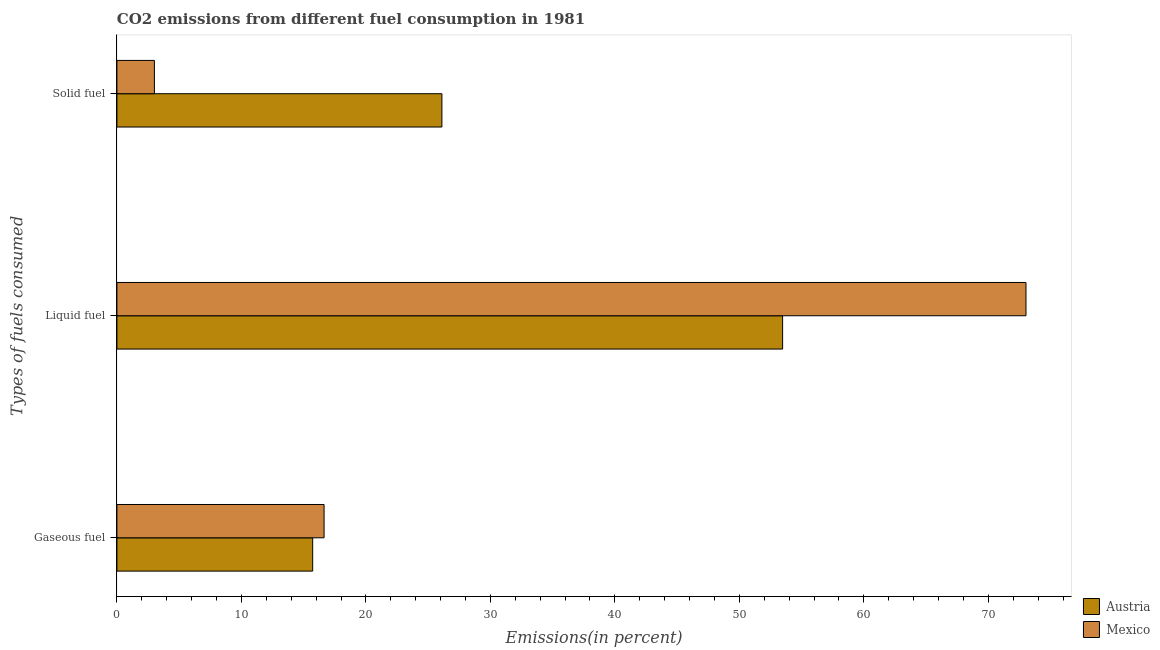How many different coloured bars are there?
Offer a terse response. 2. How many groups of bars are there?
Ensure brevity in your answer.  3. Are the number of bars on each tick of the Y-axis equal?
Your answer should be compact. Yes. How many bars are there on the 3rd tick from the top?
Your answer should be compact. 2. How many bars are there on the 3rd tick from the bottom?
Provide a succinct answer. 2. What is the label of the 3rd group of bars from the top?
Make the answer very short. Gaseous fuel. What is the percentage of liquid fuel emission in Austria?
Ensure brevity in your answer.  53.47. Across all countries, what is the maximum percentage of gaseous fuel emission?
Your response must be concise. 16.64. Across all countries, what is the minimum percentage of solid fuel emission?
Give a very brief answer. 3.01. In which country was the percentage of solid fuel emission minimum?
Make the answer very short. Mexico. What is the total percentage of solid fuel emission in the graph?
Your response must be concise. 29.12. What is the difference between the percentage of gaseous fuel emission in Austria and that in Mexico?
Make the answer very short. -0.92. What is the difference between the percentage of liquid fuel emission in Austria and the percentage of gaseous fuel emission in Mexico?
Your response must be concise. 36.83. What is the average percentage of solid fuel emission per country?
Your answer should be very brief. 14.56. What is the difference between the percentage of liquid fuel emission and percentage of solid fuel emission in Austria?
Keep it short and to the point. 27.37. In how many countries, is the percentage of gaseous fuel emission greater than 50 %?
Make the answer very short. 0. What is the ratio of the percentage of gaseous fuel emission in Austria to that in Mexico?
Keep it short and to the point. 0.94. Is the percentage of liquid fuel emission in Austria less than that in Mexico?
Provide a succinct answer. Yes. Is the difference between the percentage of solid fuel emission in Austria and Mexico greater than the difference between the percentage of liquid fuel emission in Austria and Mexico?
Your answer should be very brief. Yes. What is the difference between the highest and the second highest percentage of gaseous fuel emission?
Ensure brevity in your answer.  0.92. What is the difference between the highest and the lowest percentage of gaseous fuel emission?
Your answer should be very brief. 0.92. What does the 2nd bar from the bottom in Liquid fuel represents?
Your response must be concise. Mexico. Are all the bars in the graph horizontal?
Offer a very short reply. Yes. How many countries are there in the graph?
Ensure brevity in your answer.  2. Does the graph contain any zero values?
Give a very brief answer. No. Where does the legend appear in the graph?
Offer a very short reply. Bottom right. How are the legend labels stacked?
Ensure brevity in your answer.  Vertical. What is the title of the graph?
Ensure brevity in your answer.  CO2 emissions from different fuel consumption in 1981. Does "Central African Republic" appear as one of the legend labels in the graph?
Make the answer very short. No. What is the label or title of the X-axis?
Make the answer very short. Emissions(in percent). What is the label or title of the Y-axis?
Make the answer very short. Types of fuels consumed. What is the Emissions(in percent) of Austria in Gaseous fuel?
Offer a very short reply. 15.72. What is the Emissions(in percent) of Mexico in Gaseous fuel?
Make the answer very short. 16.64. What is the Emissions(in percent) in Austria in Liquid fuel?
Ensure brevity in your answer.  53.47. What is the Emissions(in percent) in Mexico in Liquid fuel?
Ensure brevity in your answer.  73.02. What is the Emissions(in percent) of Austria in Solid fuel?
Offer a very short reply. 26.11. What is the Emissions(in percent) in Mexico in Solid fuel?
Your answer should be compact. 3.01. Across all Types of fuels consumed, what is the maximum Emissions(in percent) in Austria?
Your answer should be very brief. 53.47. Across all Types of fuels consumed, what is the maximum Emissions(in percent) in Mexico?
Your answer should be compact. 73.02. Across all Types of fuels consumed, what is the minimum Emissions(in percent) in Austria?
Your answer should be very brief. 15.72. Across all Types of fuels consumed, what is the minimum Emissions(in percent) in Mexico?
Keep it short and to the point. 3.01. What is the total Emissions(in percent) of Austria in the graph?
Offer a very short reply. 95.3. What is the total Emissions(in percent) in Mexico in the graph?
Ensure brevity in your answer.  92.67. What is the difference between the Emissions(in percent) of Austria in Gaseous fuel and that in Liquid fuel?
Provide a short and direct response. -37.75. What is the difference between the Emissions(in percent) in Mexico in Gaseous fuel and that in Liquid fuel?
Offer a very short reply. -56.38. What is the difference between the Emissions(in percent) in Austria in Gaseous fuel and that in Solid fuel?
Give a very brief answer. -10.38. What is the difference between the Emissions(in percent) in Mexico in Gaseous fuel and that in Solid fuel?
Your answer should be very brief. 13.63. What is the difference between the Emissions(in percent) of Austria in Liquid fuel and that in Solid fuel?
Provide a short and direct response. 27.37. What is the difference between the Emissions(in percent) in Mexico in Liquid fuel and that in Solid fuel?
Make the answer very short. 70.01. What is the difference between the Emissions(in percent) of Austria in Gaseous fuel and the Emissions(in percent) of Mexico in Liquid fuel?
Keep it short and to the point. -57.3. What is the difference between the Emissions(in percent) in Austria in Gaseous fuel and the Emissions(in percent) in Mexico in Solid fuel?
Make the answer very short. 12.71. What is the difference between the Emissions(in percent) of Austria in Liquid fuel and the Emissions(in percent) of Mexico in Solid fuel?
Ensure brevity in your answer.  50.46. What is the average Emissions(in percent) in Austria per Types of fuels consumed?
Your answer should be very brief. 31.77. What is the average Emissions(in percent) of Mexico per Types of fuels consumed?
Offer a terse response. 30.89. What is the difference between the Emissions(in percent) in Austria and Emissions(in percent) in Mexico in Gaseous fuel?
Provide a short and direct response. -0.92. What is the difference between the Emissions(in percent) of Austria and Emissions(in percent) of Mexico in Liquid fuel?
Keep it short and to the point. -19.55. What is the difference between the Emissions(in percent) in Austria and Emissions(in percent) in Mexico in Solid fuel?
Your answer should be compact. 23.1. What is the ratio of the Emissions(in percent) in Austria in Gaseous fuel to that in Liquid fuel?
Provide a succinct answer. 0.29. What is the ratio of the Emissions(in percent) of Mexico in Gaseous fuel to that in Liquid fuel?
Offer a terse response. 0.23. What is the ratio of the Emissions(in percent) in Austria in Gaseous fuel to that in Solid fuel?
Your answer should be very brief. 0.6. What is the ratio of the Emissions(in percent) of Mexico in Gaseous fuel to that in Solid fuel?
Your response must be concise. 5.53. What is the ratio of the Emissions(in percent) of Austria in Liquid fuel to that in Solid fuel?
Provide a succinct answer. 2.05. What is the ratio of the Emissions(in percent) in Mexico in Liquid fuel to that in Solid fuel?
Your answer should be compact. 24.26. What is the difference between the highest and the second highest Emissions(in percent) of Austria?
Offer a terse response. 27.37. What is the difference between the highest and the second highest Emissions(in percent) of Mexico?
Provide a succinct answer. 56.38. What is the difference between the highest and the lowest Emissions(in percent) in Austria?
Ensure brevity in your answer.  37.75. What is the difference between the highest and the lowest Emissions(in percent) of Mexico?
Keep it short and to the point. 70.01. 